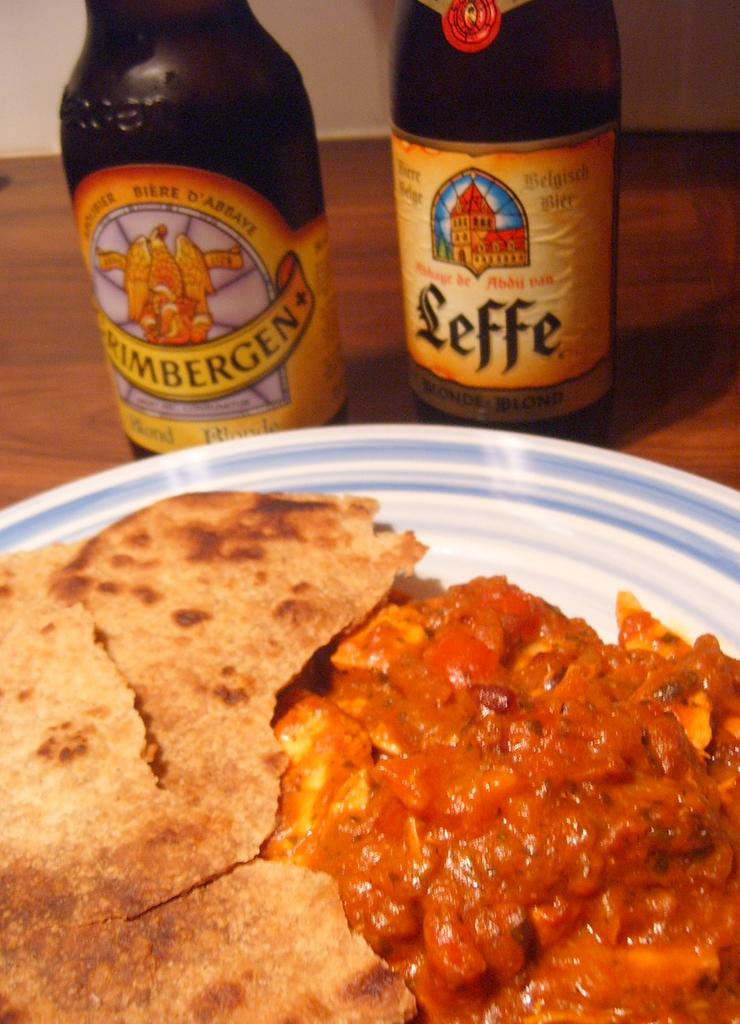What is on the plate that is visible in the image? There is food on a plate in the image. Where is the plate located in the image? The plate is on a wooden table. What else can be seen on the table besides the plate? There are two bottles of wine on the table. What material is the table made of? The table is made of wood. What type of pancake is being taught in space in the image? There is no pancake or teaching activity present in the image, nor is there any indication of a space setting. 